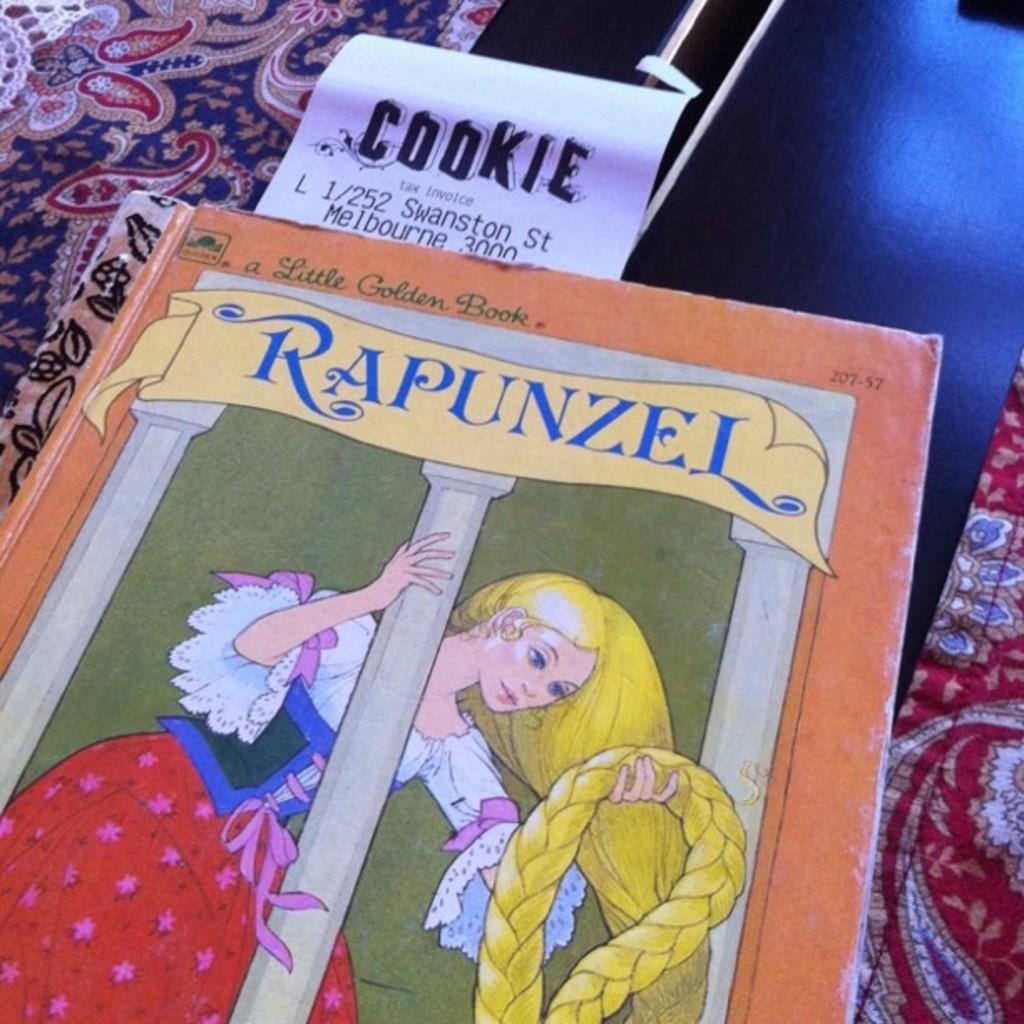What is the name of the book?
Offer a terse response. Rapunzel. 